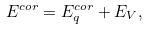<formula> <loc_0><loc_0><loc_500><loc_500>E ^ { c o r } = E _ { q } ^ { c o r } + E _ { V } ,</formula> 